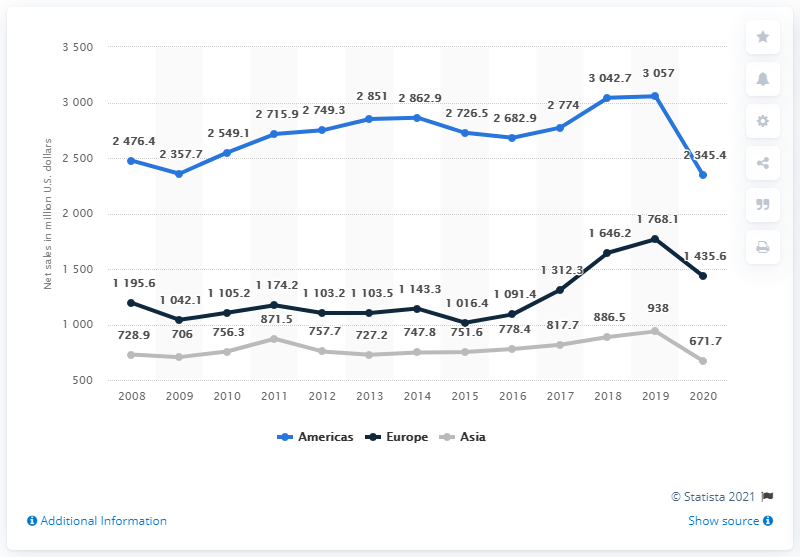Draw attention to some important aspects in this diagram. The difference between the highest sales in America and the lowest sales in Europe over the years is 2040.6. The sales of Levi Strauss in America in 2019 were the highest recorded over the years. 